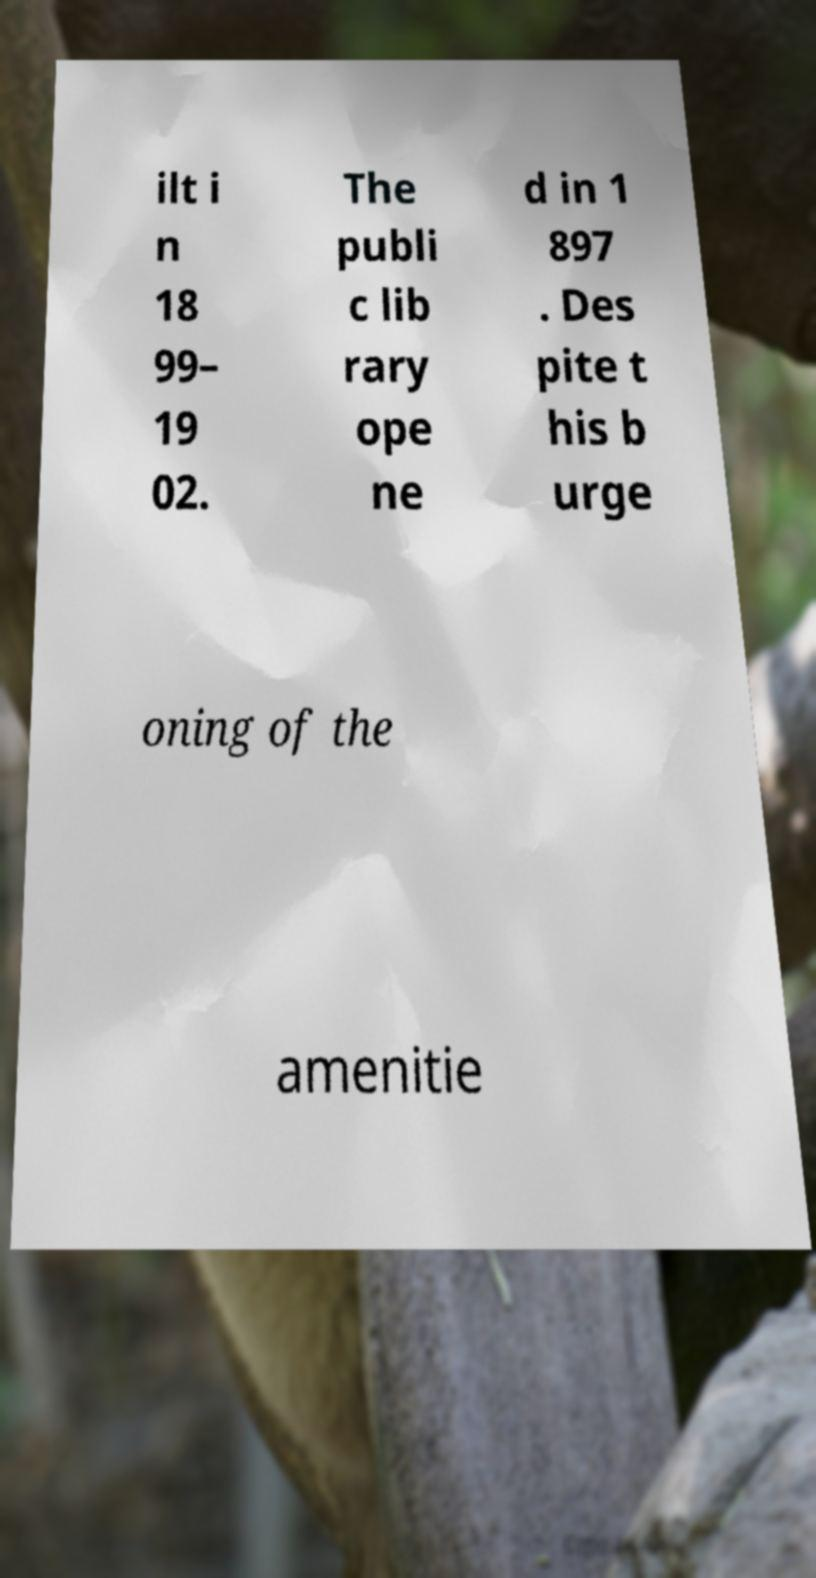There's text embedded in this image that I need extracted. Can you transcribe it verbatim? ilt i n 18 99– 19 02. The publi c lib rary ope ne d in 1 897 . Des pite t his b urge oning of the amenitie 